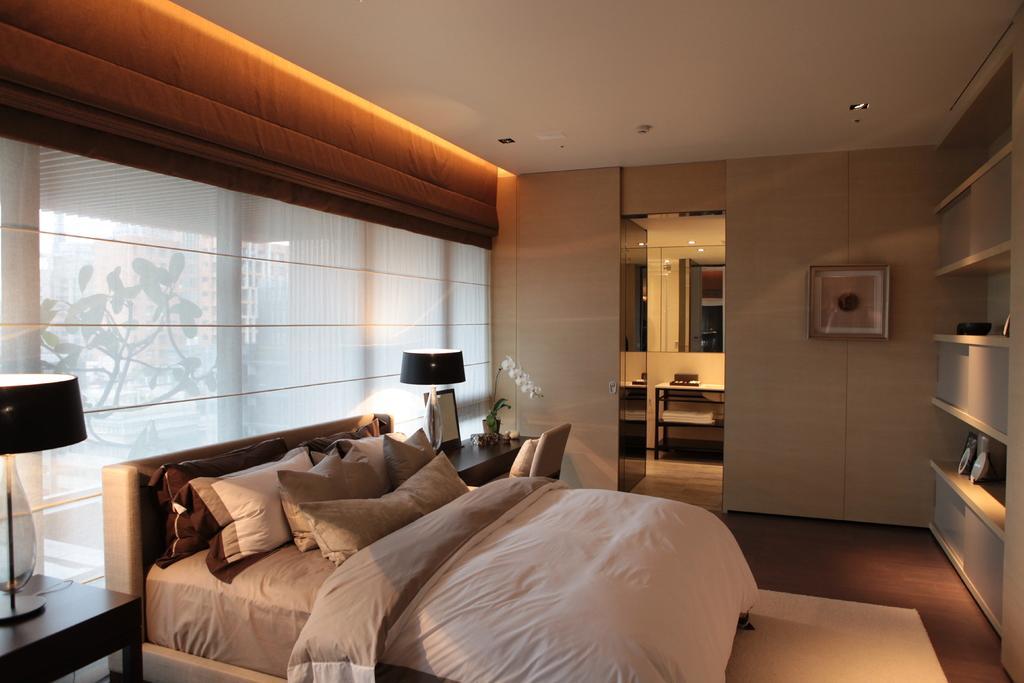Can you describe this image briefly? In this picture we can see a bed with a bed sheet, pillows on it, tables with lamps and some objects on it, chair with a pillow on it, frame on the wall, windows with curtains and some objects and from windows we can see plants, buildings. 